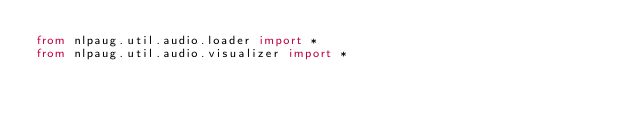<code> <loc_0><loc_0><loc_500><loc_500><_Python_>from nlpaug.util.audio.loader import *
from nlpaug.util.audio.visualizer import *
</code> 